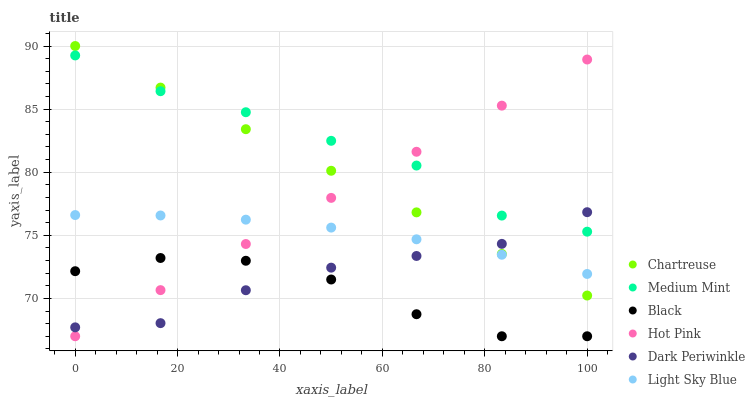Does Black have the minimum area under the curve?
Answer yes or no. Yes. Does Medium Mint have the maximum area under the curve?
Answer yes or no. Yes. Does Hot Pink have the minimum area under the curve?
Answer yes or no. No. Does Hot Pink have the maximum area under the curve?
Answer yes or no. No. Is Chartreuse the smoothest?
Answer yes or no. Yes. Is Medium Mint the roughest?
Answer yes or no. Yes. Is Hot Pink the smoothest?
Answer yes or no. No. Is Hot Pink the roughest?
Answer yes or no. No. Does Hot Pink have the lowest value?
Answer yes or no. Yes. Does Chartreuse have the lowest value?
Answer yes or no. No. Does Chartreuse have the highest value?
Answer yes or no. Yes. Does Hot Pink have the highest value?
Answer yes or no. No. Is Black less than Chartreuse?
Answer yes or no. Yes. Is Light Sky Blue greater than Black?
Answer yes or no. Yes. Does Hot Pink intersect Dark Periwinkle?
Answer yes or no. Yes. Is Hot Pink less than Dark Periwinkle?
Answer yes or no. No. Is Hot Pink greater than Dark Periwinkle?
Answer yes or no. No. Does Black intersect Chartreuse?
Answer yes or no. No. 